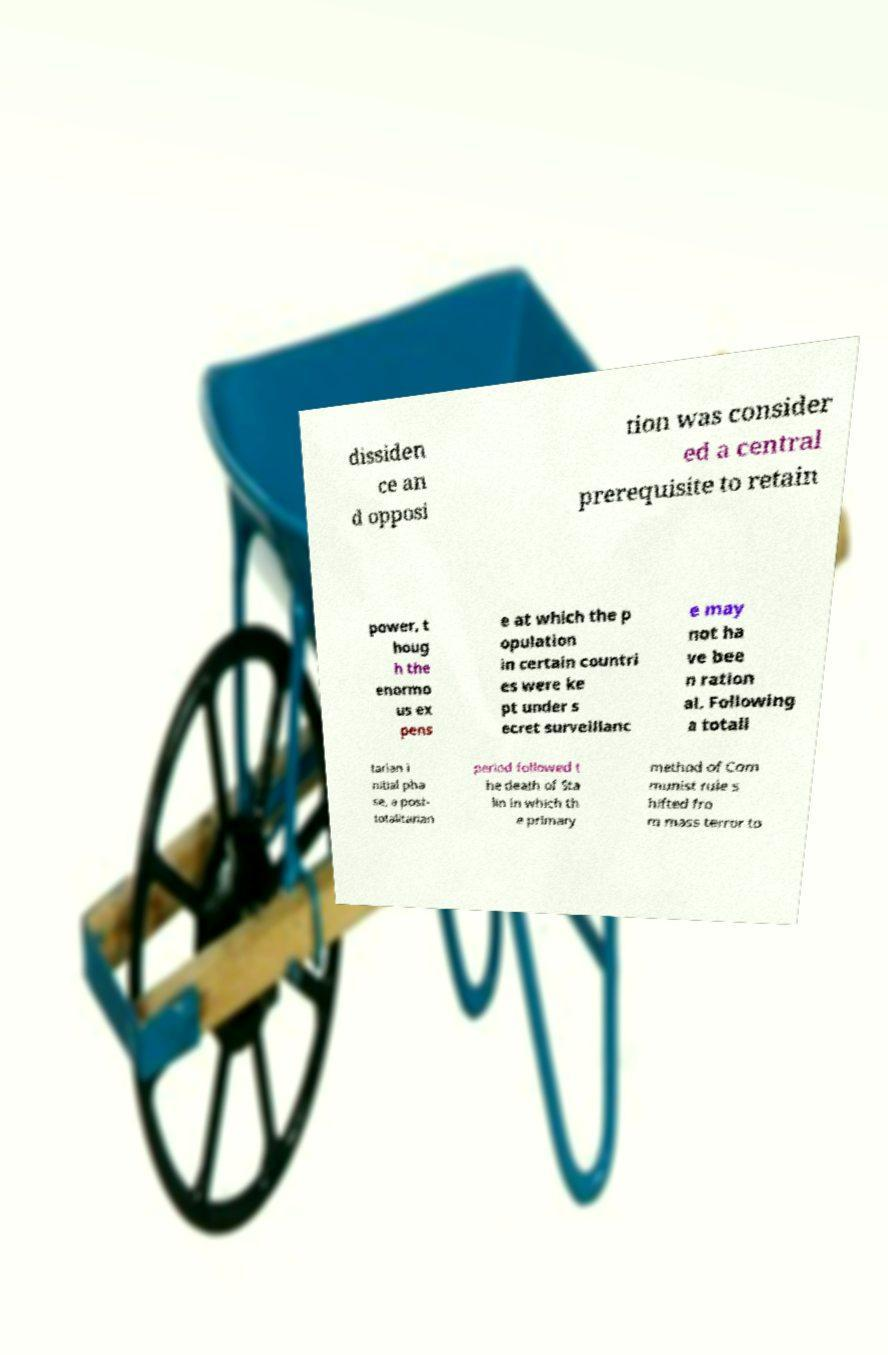What messages or text are displayed in this image? I need them in a readable, typed format. dissiden ce an d opposi tion was consider ed a central prerequisite to retain power, t houg h the enormo us ex pens e at which the p opulation in certain countri es were ke pt under s ecret surveillanc e may not ha ve bee n ration al. Following a totali tarian i nitial pha se, a post- totalitarian period followed t he death of Sta lin in which th e primary method of Com munist rule s hifted fro m mass terror to 